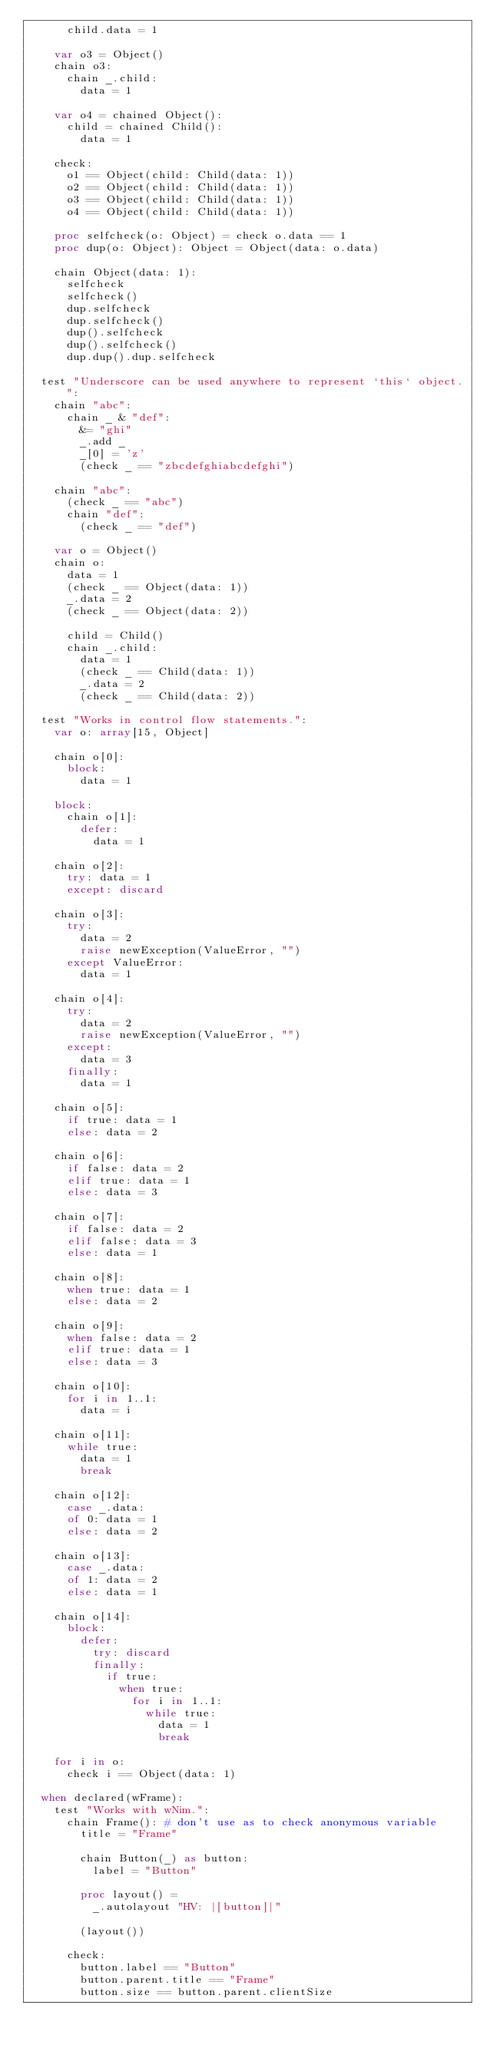<code> <loc_0><loc_0><loc_500><loc_500><_Nim_>      child.data = 1

    var o3 = Object()
    chain o3:
      chain _.child:
        data = 1

    var o4 = chained Object():
      child = chained Child():
        data = 1

    check:
      o1 == Object(child: Child(data: 1))
      o2 == Object(child: Child(data: 1))
      o3 == Object(child: Child(data: 1))
      o4 == Object(child: Child(data: 1))

    proc selfcheck(o: Object) = check o.data == 1
    proc dup(o: Object): Object = Object(data: o.data)

    chain Object(data: 1):
      selfcheck
      selfcheck()
      dup.selfcheck
      dup.selfcheck()
      dup().selfcheck
      dup().selfcheck()
      dup.dup().dup.selfcheck

  test "Underscore can be used anywhere to represent `this` object.":
    chain "abc":
      chain _ & "def":
        &= "ghi"
        _.add _
        _[0] = 'z'
        (check _ == "zbcdefghiabcdefghi")

    chain "abc":
      (check _ == "abc")
      chain "def":
        (check _ == "def")

    var o = Object()
    chain o:
      data = 1
      (check _ == Object(data: 1))
      _.data = 2
      (check _ == Object(data: 2))

      child = Child()
      chain _.child:
        data = 1
        (check _ == Child(data: 1))
        _.data = 2
        (check _ == Child(data: 2))

  test "Works in control flow statements.":
    var o: array[15, Object]

    chain o[0]:
      block:
        data = 1

    block:
      chain o[1]:
        defer:
          data = 1

    chain o[2]:
      try: data = 1
      except: discard

    chain o[3]:
      try:
        data = 2
        raise newException(ValueError, "")
      except ValueError:
        data = 1

    chain o[4]:
      try:
        data = 2
        raise newException(ValueError, "")
      except:
        data = 3
      finally:
        data = 1

    chain o[5]:
      if true: data = 1
      else: data = 2

    chain o[6]:
      if false: data = 2
      elif true: data = 1
      else: data = 3

    chain o[7]:
      if false: data = 2
      elif false: data = 3
      else: data = 1

    chain o[8]:
      when true: data = 1
      else: data = 2

    chain o[9]:
      when false: data = 2
      elif true: data = 1
      else: data = 3

    chain o[10]:
      for i in 1..1:
        data = i

    chain o[11]:
      while true:
        data = 1
        break

    chain o[12]:
      case _.data:
      of 0: data = 1
      else: data = 2

    chain o[13]:
      case _.data:
      of 1: data = 2
      else: data = 1

    chain o[14]:
      block:
        defer:
          try: discard
          finally:
            if true:
              when true:
                for i in 1..1:
                  while true:
                    data = 1
                    break

    for i in o:
      check i == Object(data: 1)

  when declared(wFrame):
    test "Works with wNim.":
      chain Frame(): # don't use as to check anonymous variable
        title = "Frame"

        chain Button(_) as button:
          label = "Button"

        proc layout() =
          _.autolayout "HV: |[button]|"

        (layout())

      check:
        button.label == "Button"
        button.parent.title == "Frame"
        button.size == button.parent.clientSize
</code> 